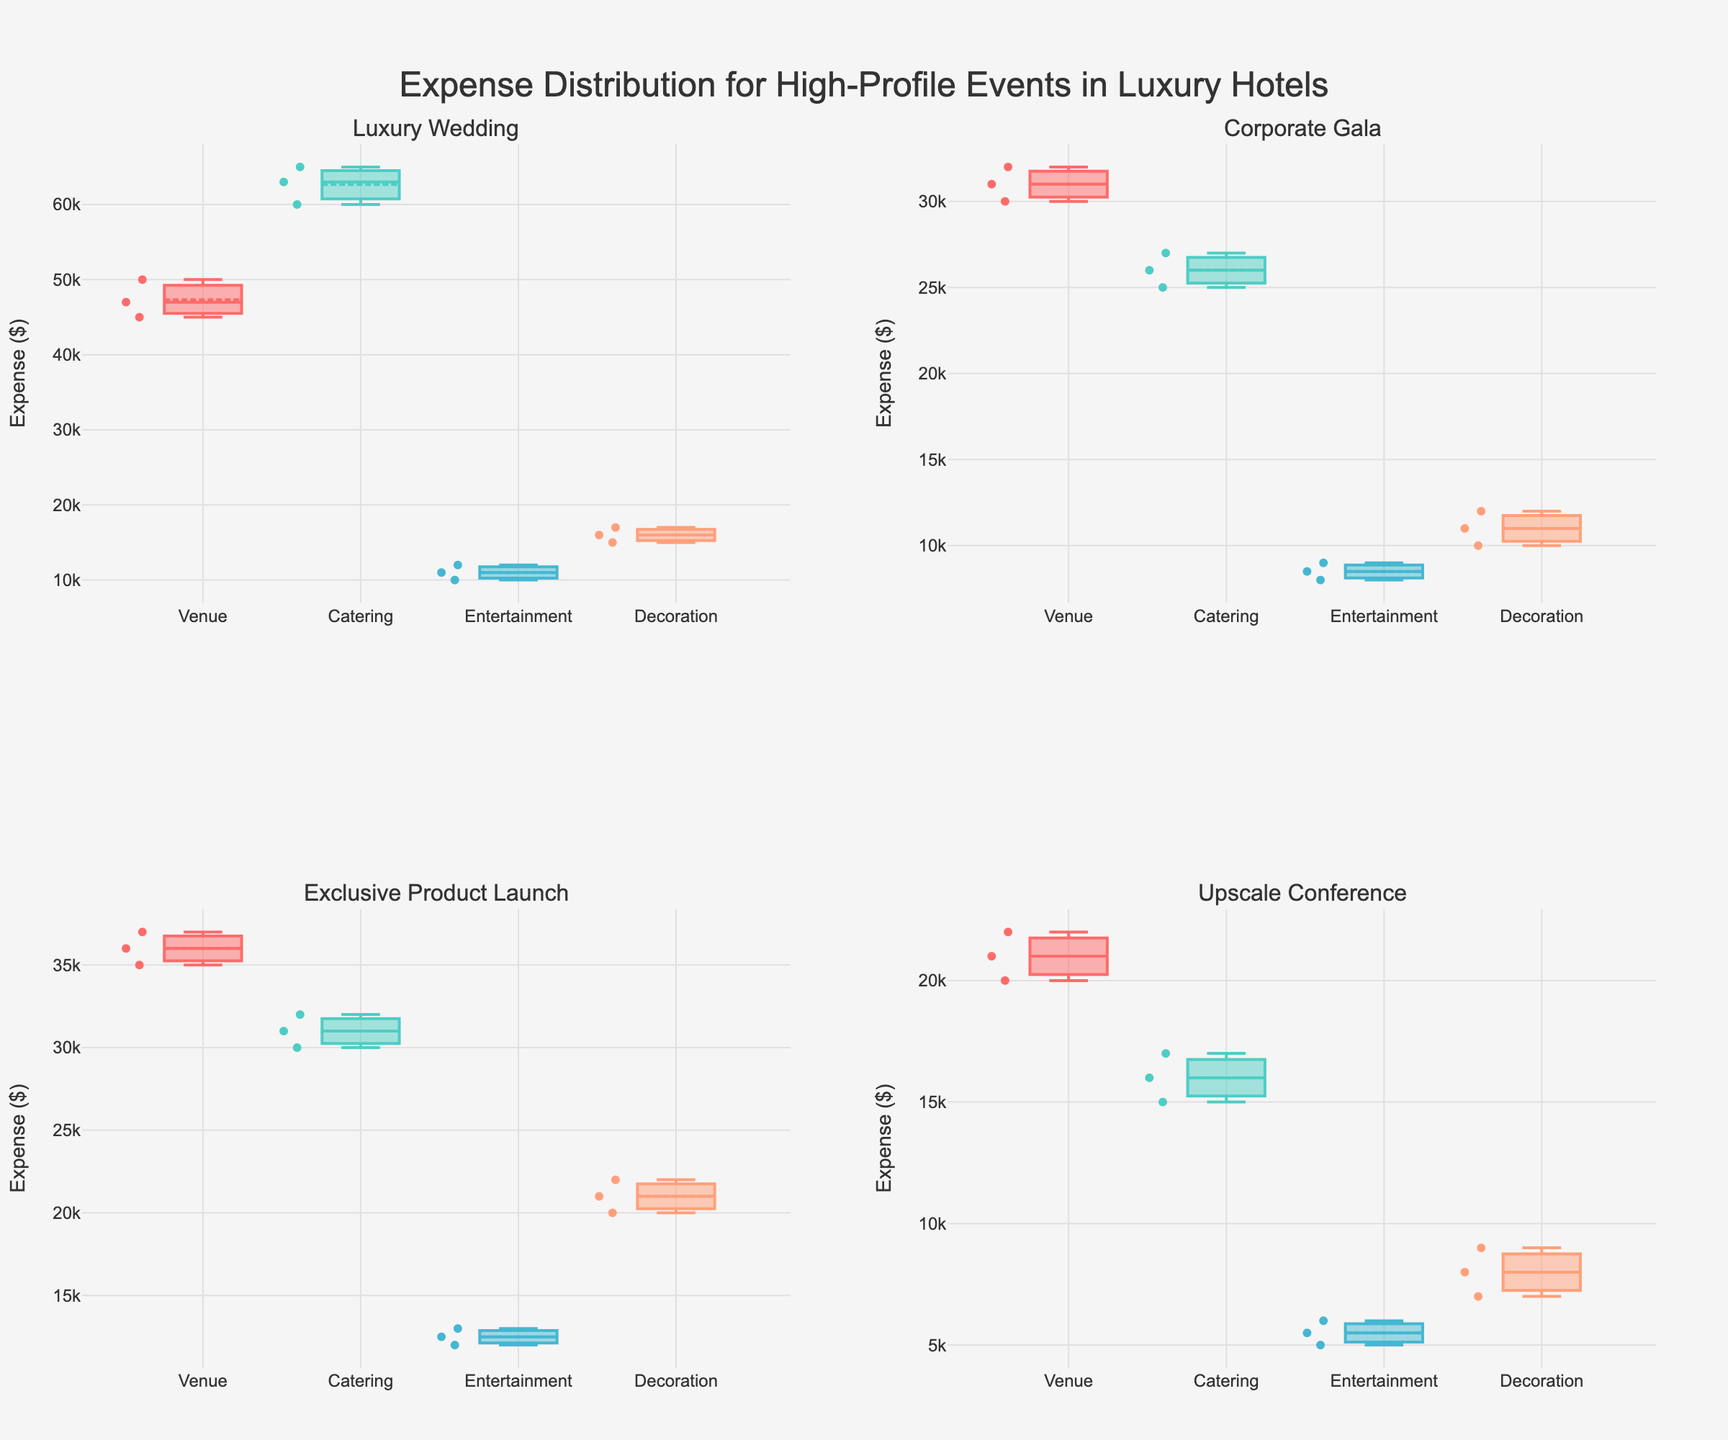What is the title of the figure? The title is usually located at the top of the figure. From the code, we see it is set under `title`.
Answer: Expense Distribution for High-Profile Events in Luxury Hotels How many subplots are there in the figure? By reading the description in the code, we know that we create a subplot for each unique event type, and there are 4 event types in total. Therefore, there are 4 subplots.
Answer: 4 Which event category has the highest median expense for Luxury Weddings? In the subplot titled "Luxury Wedding", compare the medians for each category (Venue, Catering, Entertainment, Decoration) indicated by the horizontal lines within the boxes. According to the provided data, Catering has the highest median.
Answer: Catering What is the range of expenses for Entertainment in the Upscale Conference? In the subplot titled "Upscale Conference", look at the extent of the whiskers (lines) above and below the box for the Entertainment category. The data shows expenses ranging from $5,000 to $6,000.
Answer: $5,000 to $6,000 Which event type has the lowest median venue expense? Compare the medians of the Venue categories across all subplots. The Upscale Conference has the lowest visible median for Venue expenses.
Answer: Upscale Conference For Corporate Galas, which expense category shows the largest spread (difference between maximum and minimum expense)? Within the subplot for "Corporate Gala", compare the range of values for each category (indicated by the whiskers' extent). Venue has the expenses ranging from $30,000 to $32,000, suggesting the largest spread.
Answer: Venue What is the median expense for Decoration in Exclusive Product Launch events? In the subplot for "Exclusive Product Launch", determine the median of Decoration by referencing the horizontal line within the Decoration category’s box. The data suggests a median of $21,000.
Answer: $21,000 How do the expense distributions for Catering in Corporate Galas and Exclusive Product Launches compare? Compare the two subplots, focusing on the Catering category in each. Observe the median lines and the spread of the boxes and whiskers; Exclusive Product Launches generally feature higher median and wider range compared to Corporate Galas.
Answer: Exclusive Product Launches have higher median and wider range In which event type is the expense distribution for Decoration the most spread out? Assess the range (whiskers' distances and box height) for Decoration in all subplots. The Exclusive Product Launch shows the widest range from $20,000 to $22,000, indicating the largest spread.
Answer: Exclusive Product Launch 